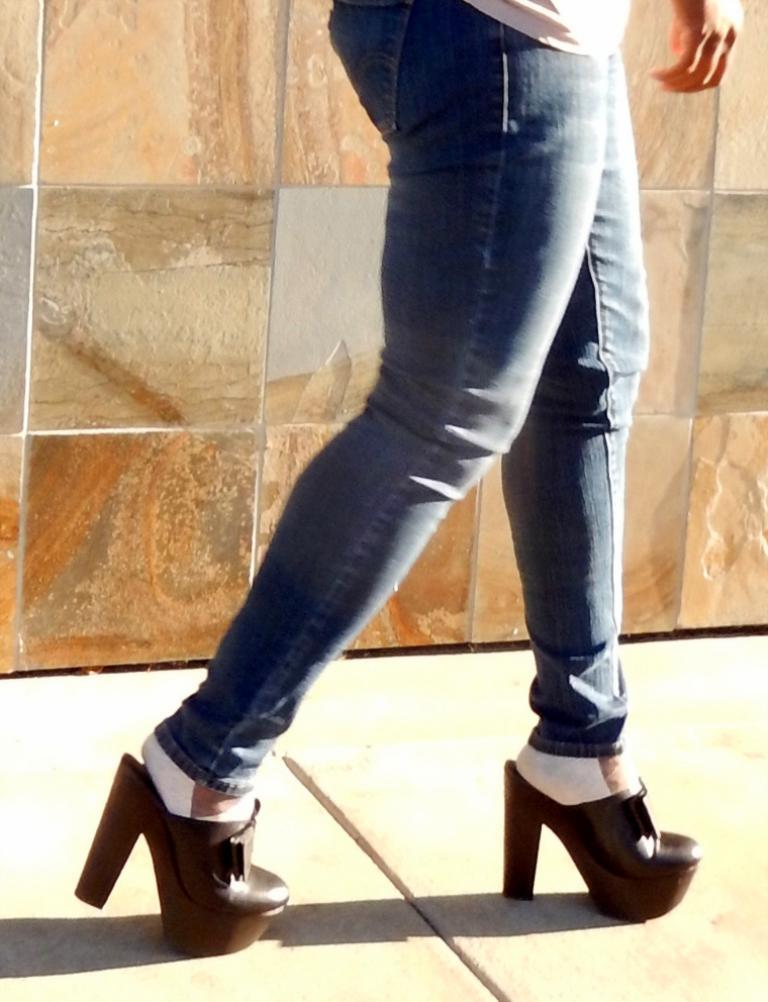What is the main subject of the image? There is a person in the image. What is the person doing in the image? The person is walking on the floor. What can be seen in the background of the image? There is a wall visible in the background of the image. What type of blade is being used by the person in the image? There is no blade present in the image; the person is simply walking on the floor. 